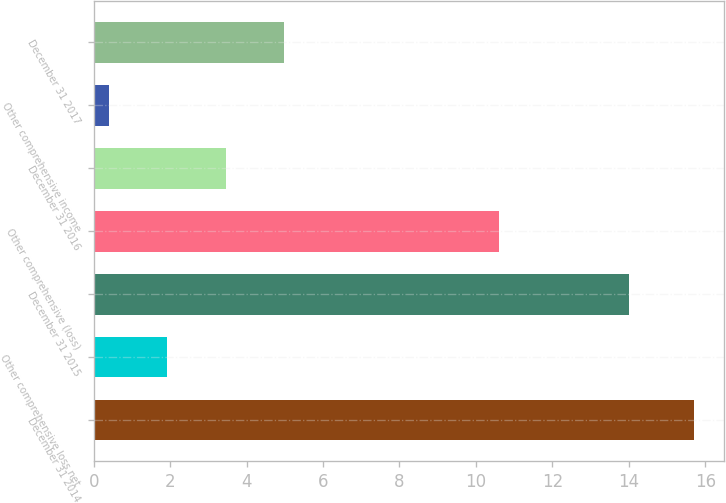Convert chart. <chart><loc_0><loc_0><loc_500><loc_500><bar_chart><fcel>December 31 2014<fcel>Other comprehensive loss net<fcel>December 31 2015<fcel>Other comprehensive (loss)<fcel>December 31 2016<fcel>Other comprehensive income<fcel>December 31 2017<nl><fcel>15.7<fcel>1.93<fcel>14<fcel>10.6<fcel>3.46<fcel>0.4<fcel>4.99<nl></chart> 